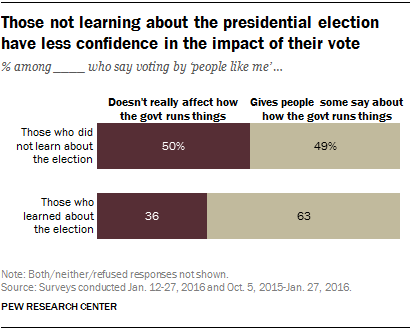Outline some significant characteristics in this image. The option that has a minimal impact on how the government operates and is not substantial in terms of percentage value is those who did not learn about the election. There are two colors in the chart. 